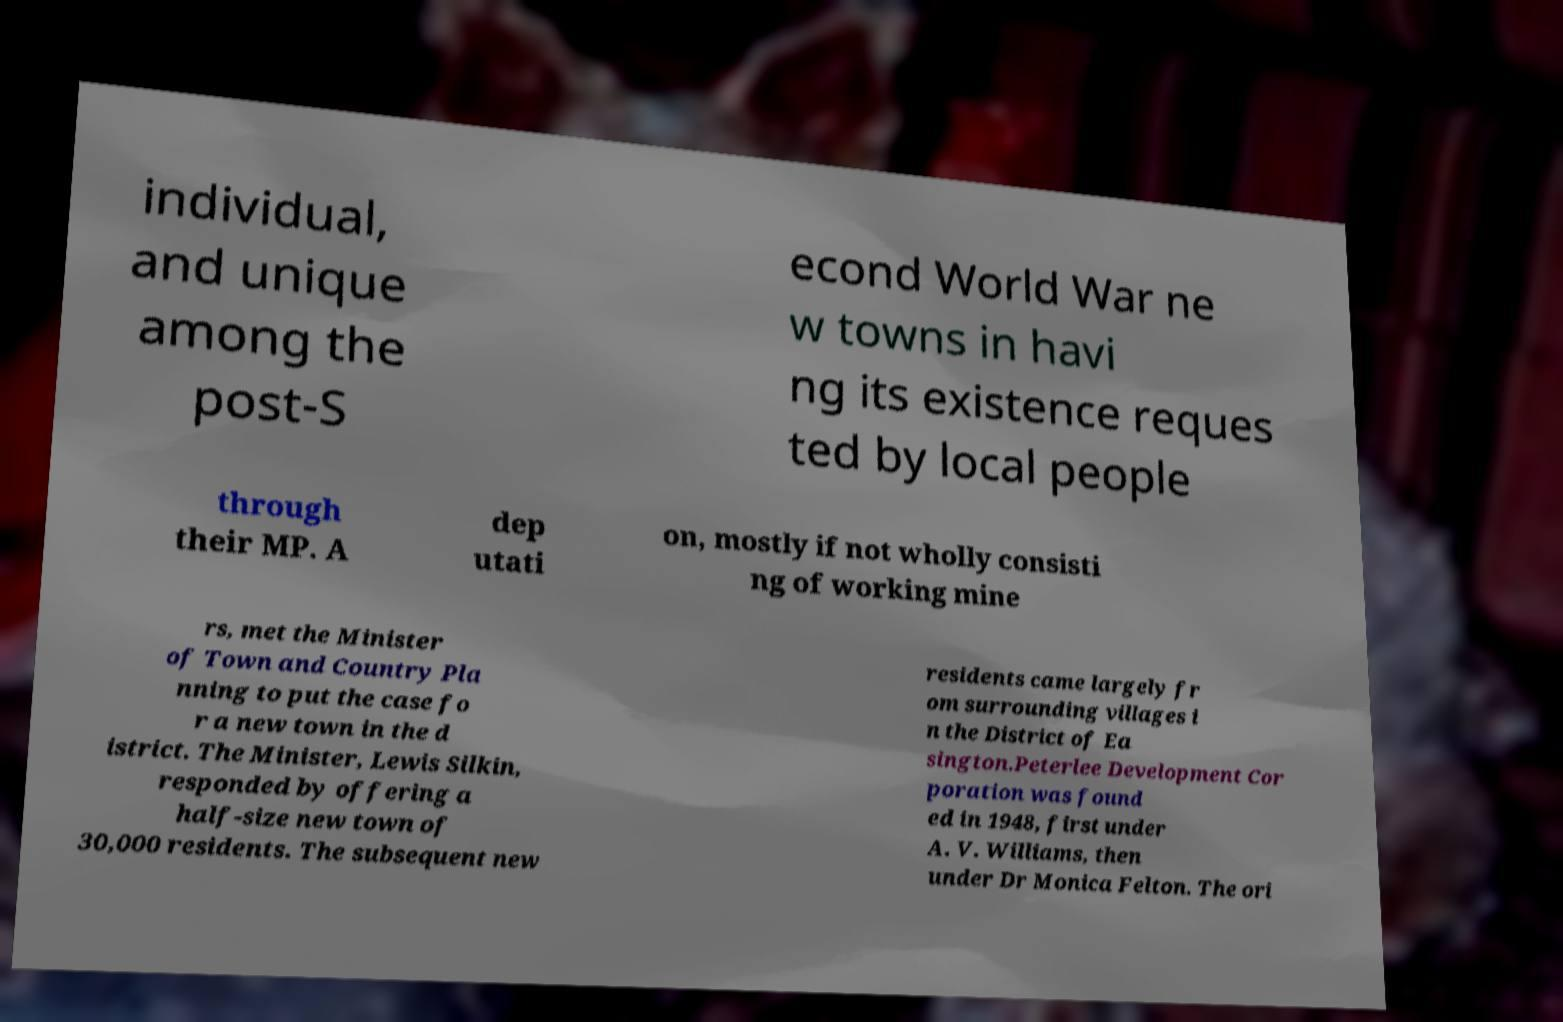For documentation purposes, I need the text within this image transcribed. Could you provide that? individual, and unique among the post-S econd World War ne w towns in havi ng its existence reques ted by local people through their MP. A dep utati on, mostly if not wholly consisti ng of working mine rs, met the Minister of Town and Country Pla nning to put the case fo r a new town in the d istrict. The Minister, Lewis Silkin, responded by offering a half-size new town of 30,000 residents. The subsequent new residents came largely fr om surrounding villages i n the District of Ea sington.Peterlee Development Cor poration was found ed in 1948, first under A. V. Williams, then under Dr Monica Felton. The ori 